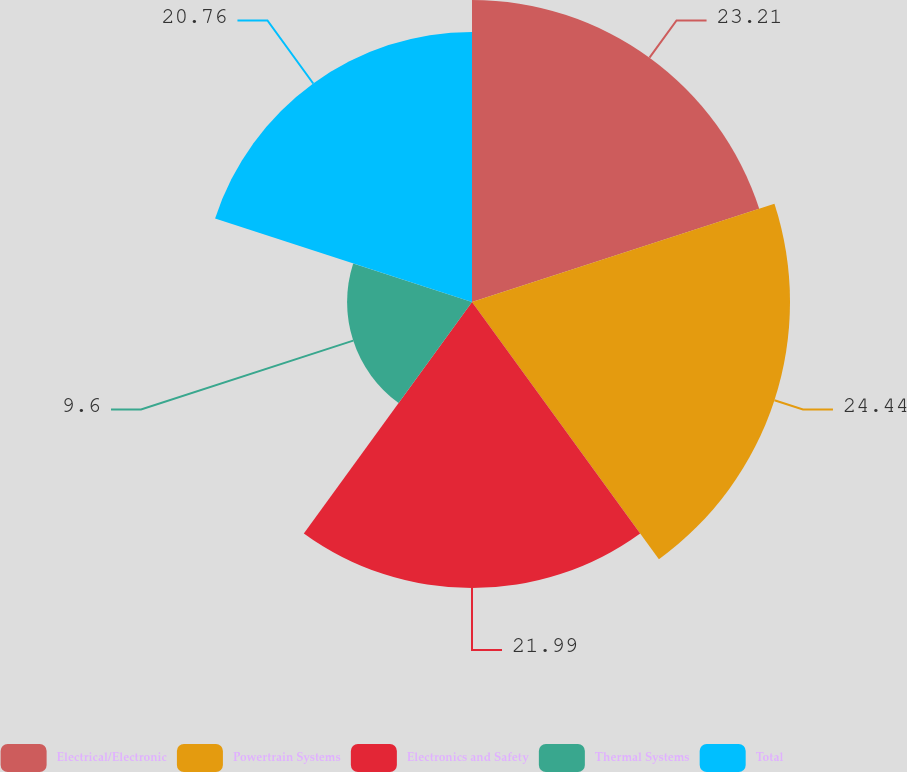Convert chart. <chart><loc_0><loc_0><loc_500><loc_500><pie_chart><fcel>Electrical/Electronic<fcel>Powertrain Systems<fcel>Electronics and Safety<fcel>Thermal Systems<fcel>Total<nl><fcel>23.21%<fcel>24.44%<fcel>21.99%<fcel>9.6%<fcel>20.76%<nl></chart> 